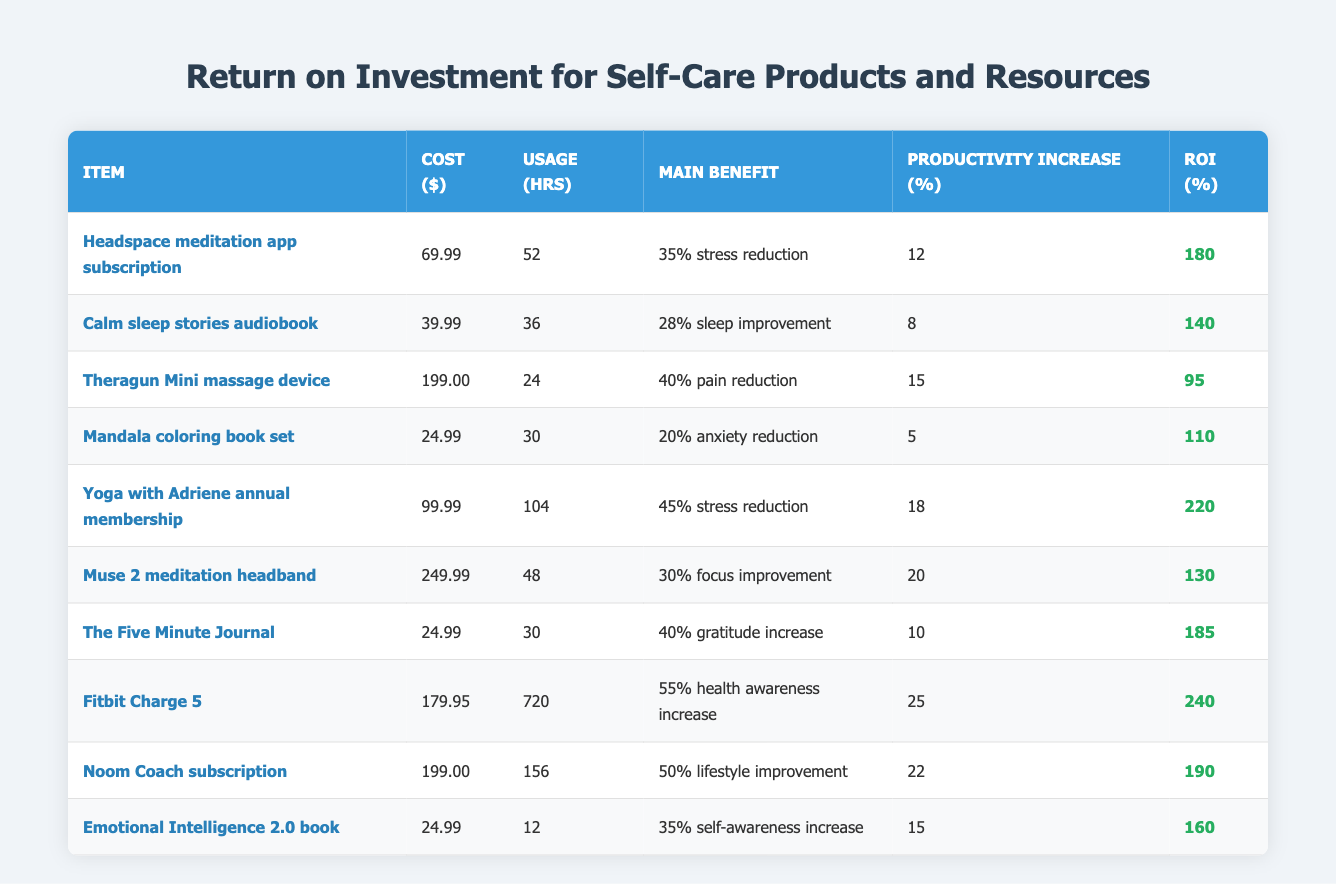What is the cost of the Yoga with Adriene annual membership? The table lists the cost of the Yoga with Adriene annual membership in the second column under "Cost ($)", which is 99.99.
Answer: 99.99 Which product has the highest reported health awareness increase? In the table, the Fitbit Charge 5 shows a reported health awareness increase of 55%, which is the highest among all products.
Answer: Fitbit Charge 5 What is the average ROI percentage for all the items? To calculate the average ROI, add the ROI percentages: (180 + 140 + 95 + 110 + 220 + 130 + 185 + 240 + 190 + 160) = 1,610. There are 10 items, so dividing gives 1,610 / 10 = 161.
Answer: 161 Is the emotional intelligence book the least expensive product available? The table indicates that the Emotional Intelligence 2.0 book has a cost of 24.99, and when compared to other products in the same column, it is indeed the least expensive.
Answer: Yes Which self-care item shows the greatest productivity increase, and what is that increase? By examining the Productivity Increase (%) column, the Fitbit Charge 5 shows a 25% increase, which is the highest among the listed items.
Answer: Fitbit Charge 5, 25% What is the difference in reported stress reduction between the Yoga with Adriene membership and the Calm sleep stories audiobook? The Yoga with Adriene membership reports a 45% stress reduction, while the Calm sleep stories audiobook reports 28%. The difference is 45 - 28 = 17.
Answer: 17 Are clients reporting a higher increase in self-awareness from the Emotional Intelligence 2.0 book than from the Calm sleep stories audiobook? The table shows that the Emotional Intelligence 2.0 book has a reported self-awareness increase of 35%, while the Calm sleep stories audiobook shows a 28% improvement. Therefore, clients report a higher increase from the Emotional Intelligence book.
Answer: Yes How much does the Theragun Mini cost, and what is the reported pain reduction percentage? The table indicates that the Theragun Mini costs 199.00 and has a reported pain reduction of 40%.
Answer: 199.00, 40% What is the combined cost of the Mandala coloring book set and The Five Minute Journal? The cost of the Mandala coloring book set is 24.99, and the cost of The Five Minute Journal is 24.99. Adding these together: 24.99 + 24.99 = 49.98.
Answer: 49.98 